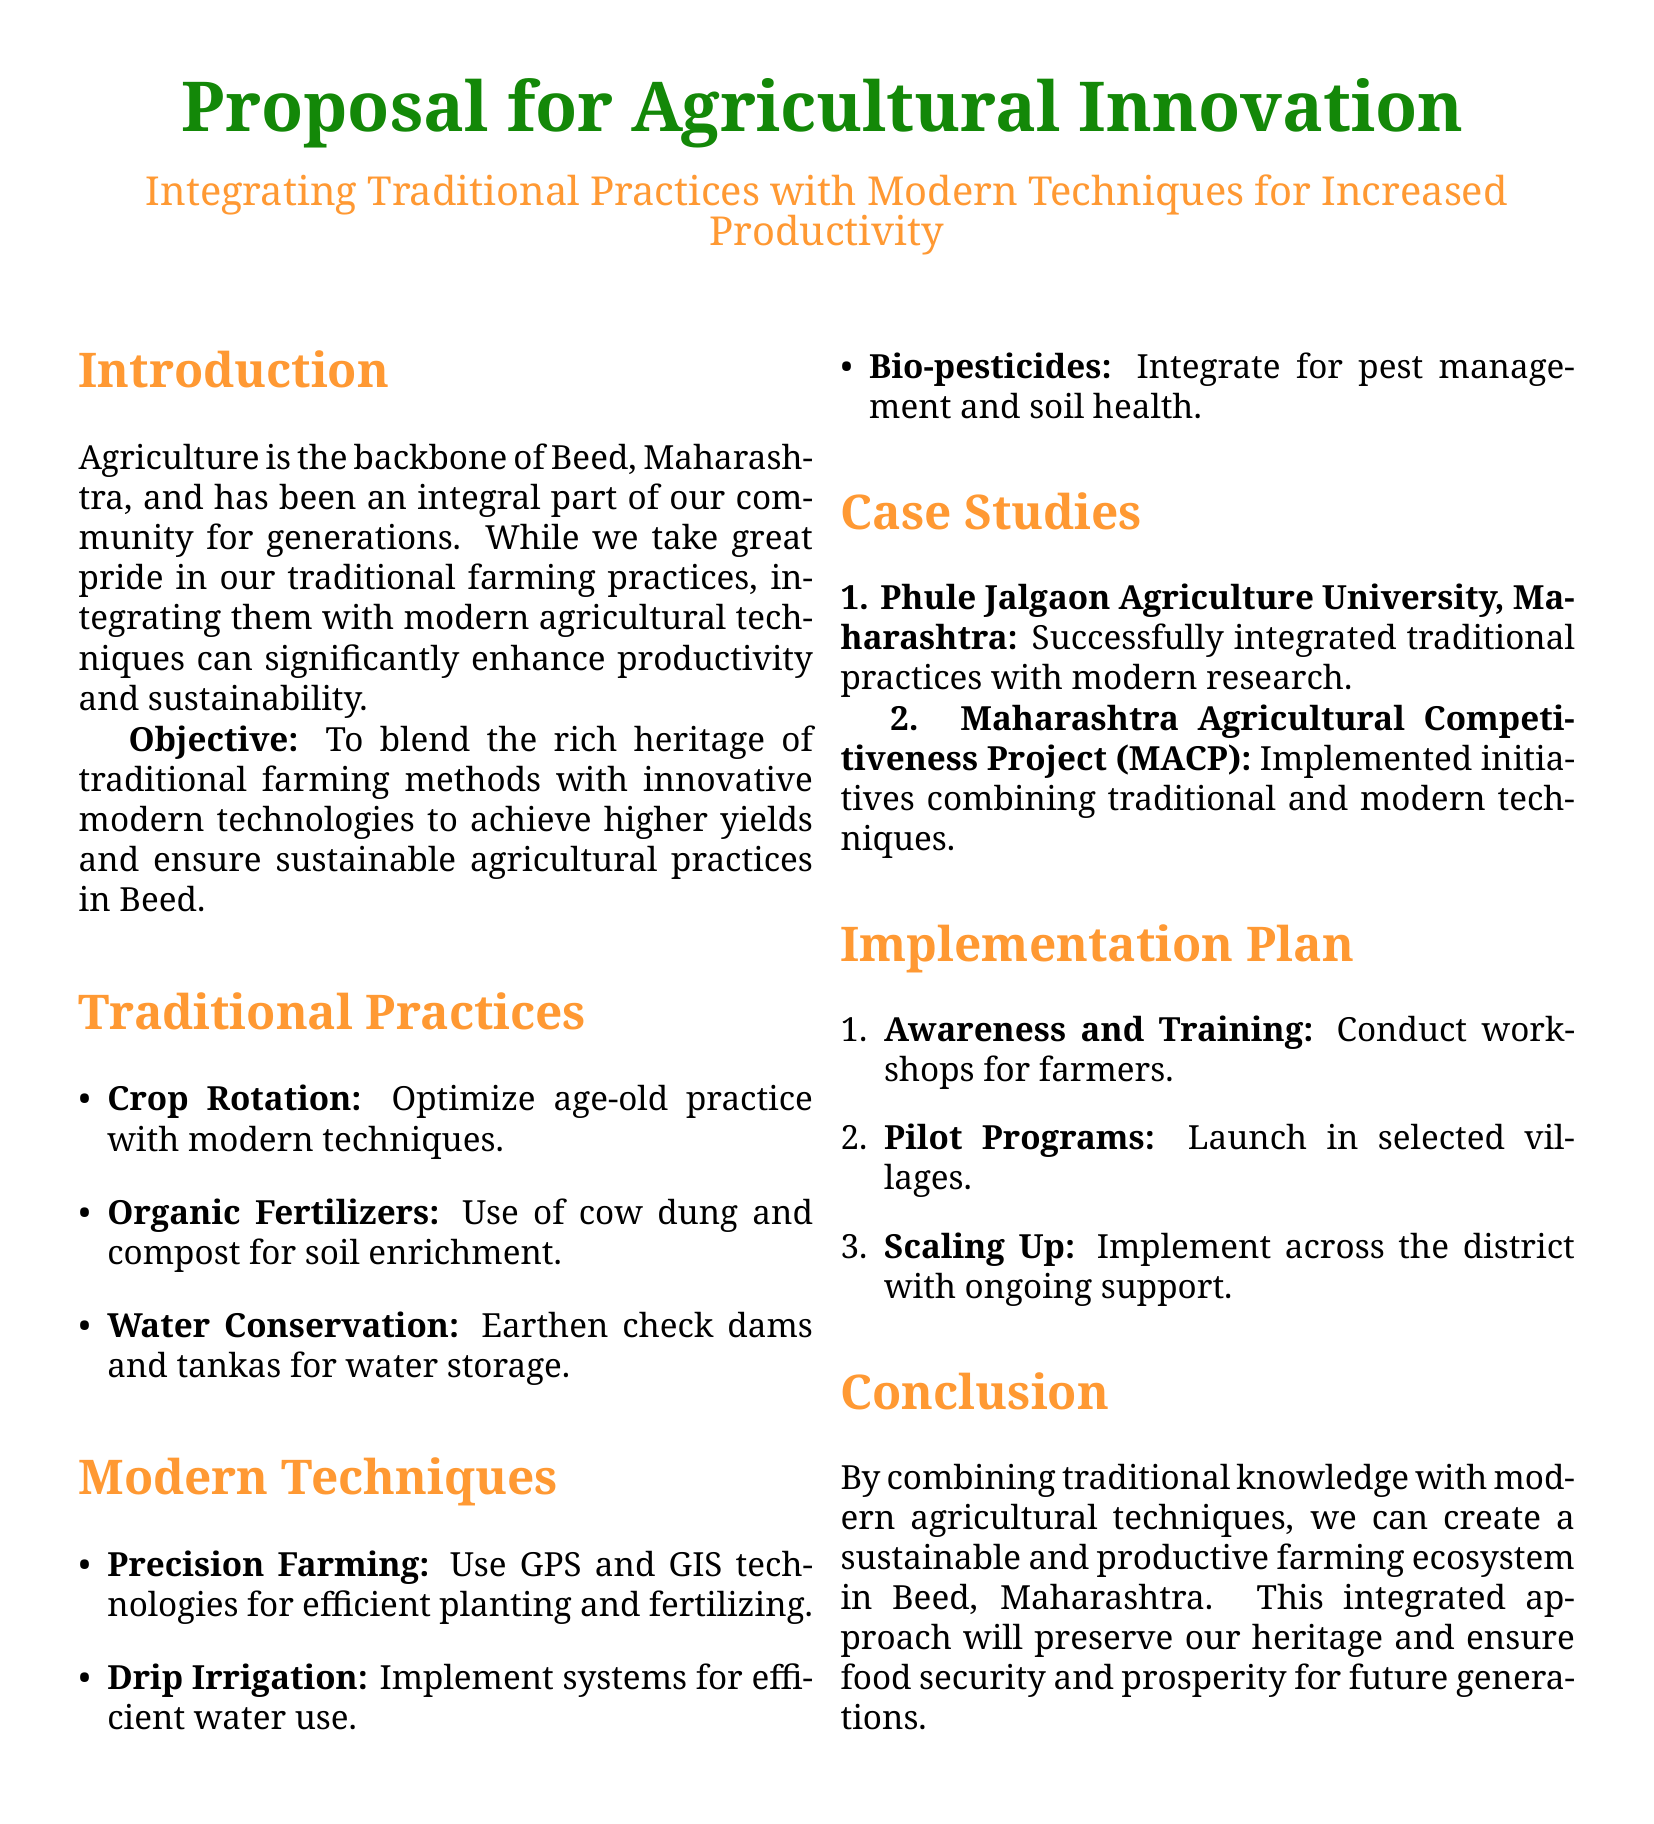What is the main objective of the proposal? The objective is to blend traditional farming methods with modern technologies for increased productivity.
Answer: To blend the rich heritage of traditional farming methods with innovative modern technologies What traditional practice is focused on soil enrichment? The document mentions the use of specific organic materials for soil improvement.
Answer: Use of cow dung and compost Which modern technique involves the use of precision tools for planting? The document discusses a modern agricultural approach that utilizes technology for efficiency.
Answer: Precision Farming What university is mentioned as a case study? A specific educational institution is highlighted for its integration of practices in agriculture.
Answer: Phule Jalgaon Agriculture University, Maharashtra What is the first step in the implementation plan? The document outlines a process to begin the integration of practices, starting with educating farmers.
Answer: Conduct workshops for farmers How many case studies are mentioned in the proposal? The document provides examples to illustrate the effectiveness of the stated practices.
Answer: 2 What type of irrigation system is proposed for efficient water use? A specific irrigation method is highlighted for resource conservation.
Answer: Drip Irrigation What is one method suggested for water conservation? The document mentions traditional techniques for managing and conserving water resources.
Answer: Earthen check dams and tankas What is emphasized as essential for ensuring food security in the conclusion? The conclusion highlights the significance of combining practices for future sustainability.
Answer: Sustainable and productive farming ecosystem 